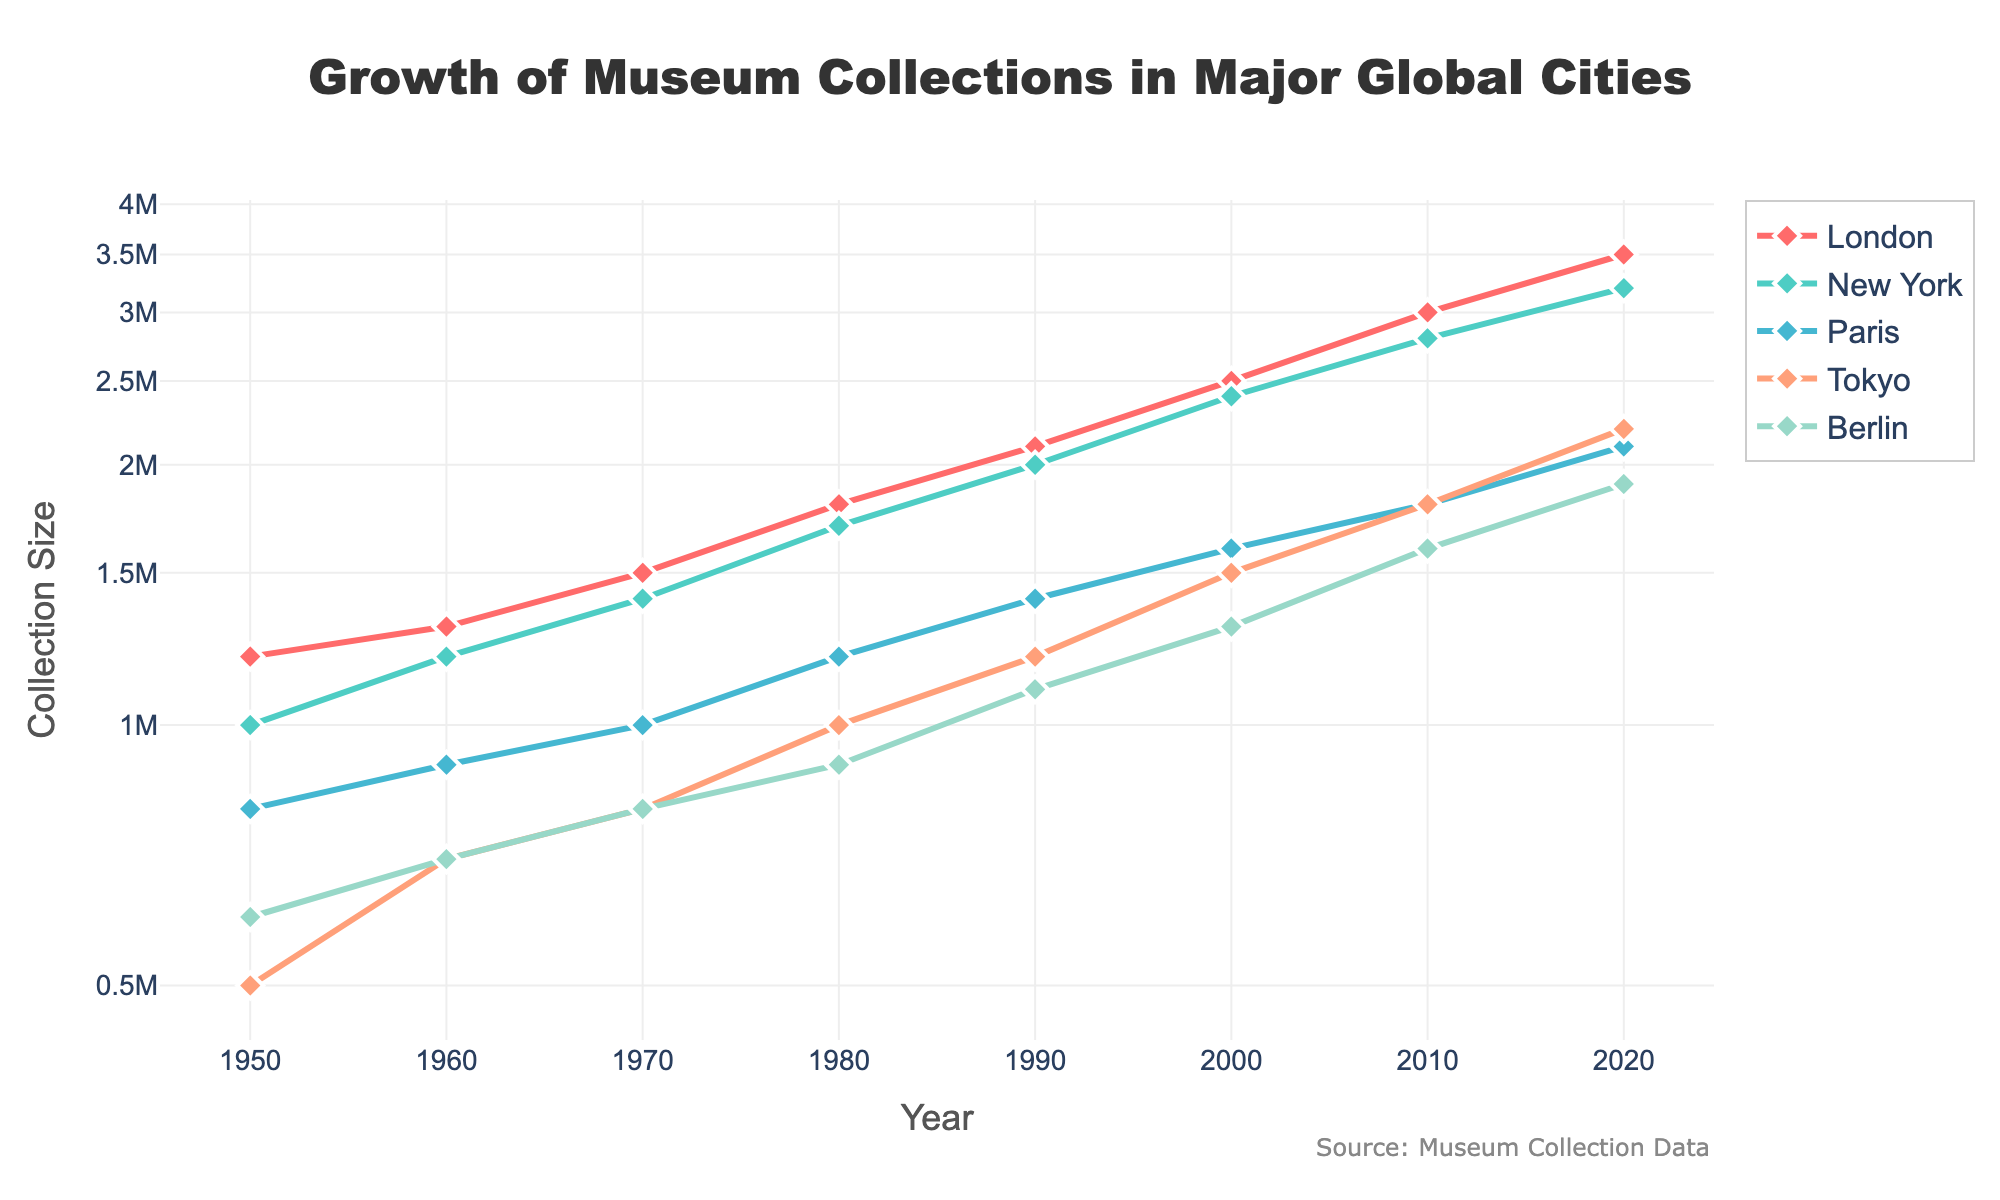What's the title of the plot? The title is usually displayed at the top of the figure. In this case, the title is "Growth of Museum Collections in Major Global Cities".
Answer: Growth of Museum Collections in Major Global Cities Which city had the largest collection size in 2020? By examining the plot's data points for the year 2020, we can see that London had the largest collection size.
Answer: London How many cities are represented in the plot? The plot contains five lines, each representing a different city: London, New York, Paris, Tokyo, and Berlin.
Answer: 5 What is the y-axis scale of the plot? The y-axis scale is labeled with a logarithmic scale, often used to represent data that spans several orders of magnitude.
Answer: Logarithmic Between which two years did New York's collection size grow the most rapidly? By observing the slope of New York's line, the steepest increase is between 1950 and 1960.
Answer: 1950 and 1960 Which city had the smallest collection size in 1950? By looking at the data points for the year 1950, Tokyo had the smallest collection size.
Answer: Tokyo By how much did Berlin’s collection size increase from 1950 to 2020? The collection size in Berlin in 1950 was 600,000 and in 2020 it was 1,900,000. The difference is 1,900,000 - 600,000 = 1,300,000.
Answer: 1,300,000 Which city’s collection size was closest to 1,000,000 in 1980? Looking at the year 1980, the data points show that Tokyo's collection size was closest to 1,000,000.
Answer: Tokyo How does the growth trend of Paris compare to Tokyo's over the entire period? Both cities show steady growth; however, Tokyo starts with a smaller collection size and grows faster, surpassing Paris between 2010 and 2020.
Answer: Tokyo grows faster What is the collection size difference between London and Paris in 2000? London's collection size in 2000 was 2,500,000 and Paris's was 1,600,000. The difference is 2,500,000 - 1,600,000 = 900,000.
Answer: 900,000 